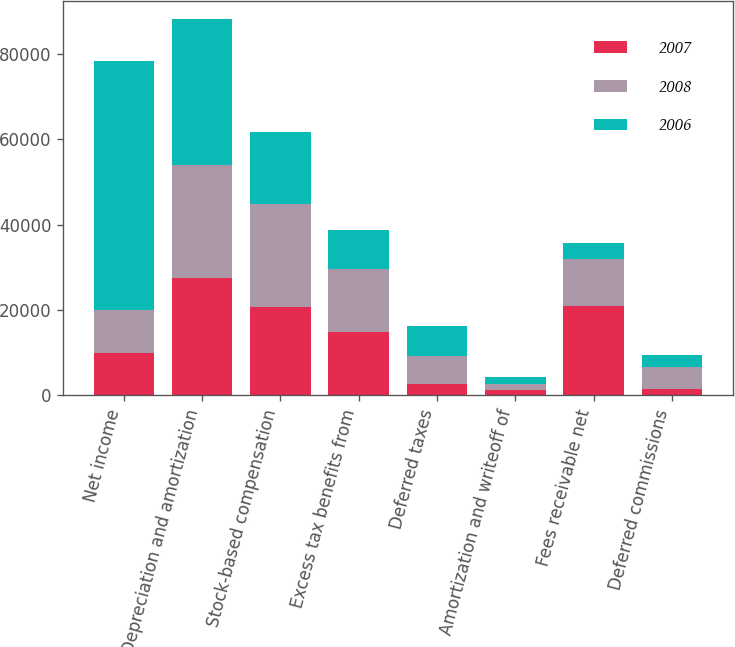Convert chart. <chart><loc_0><loc_0><loc_500><loc_500><stacked_bar_chart><ecel><fcel>Net income<fcel>Depreciation and amortization<fcel>Stock-based compensation<fcel>Excess tax benefits from<fcel>Deferred taxes<fcel>Amortization and writeoff of<fcel>Fees receivable net<fcel>Deferred commissions<nl><fcel>2007<fcel>10019.5<fcel>27495<fcel>20696<fcel>14831<fcel>2617<fcel>1222<fcel>20987<fcel>1403<nl><fcel>2008<fcel>10019.5<fcel>26389<fcel>24241<fcel>14759<fcel>6740<fcel>1363<fcel>10880<fcel>5266<nl><fcel>2006<fcel>58192<fcel>34197<fcel>16660<fcel>9159<fcel>6830<fcel>1627<fcel>3876<fcel>2774<nl></chart> 